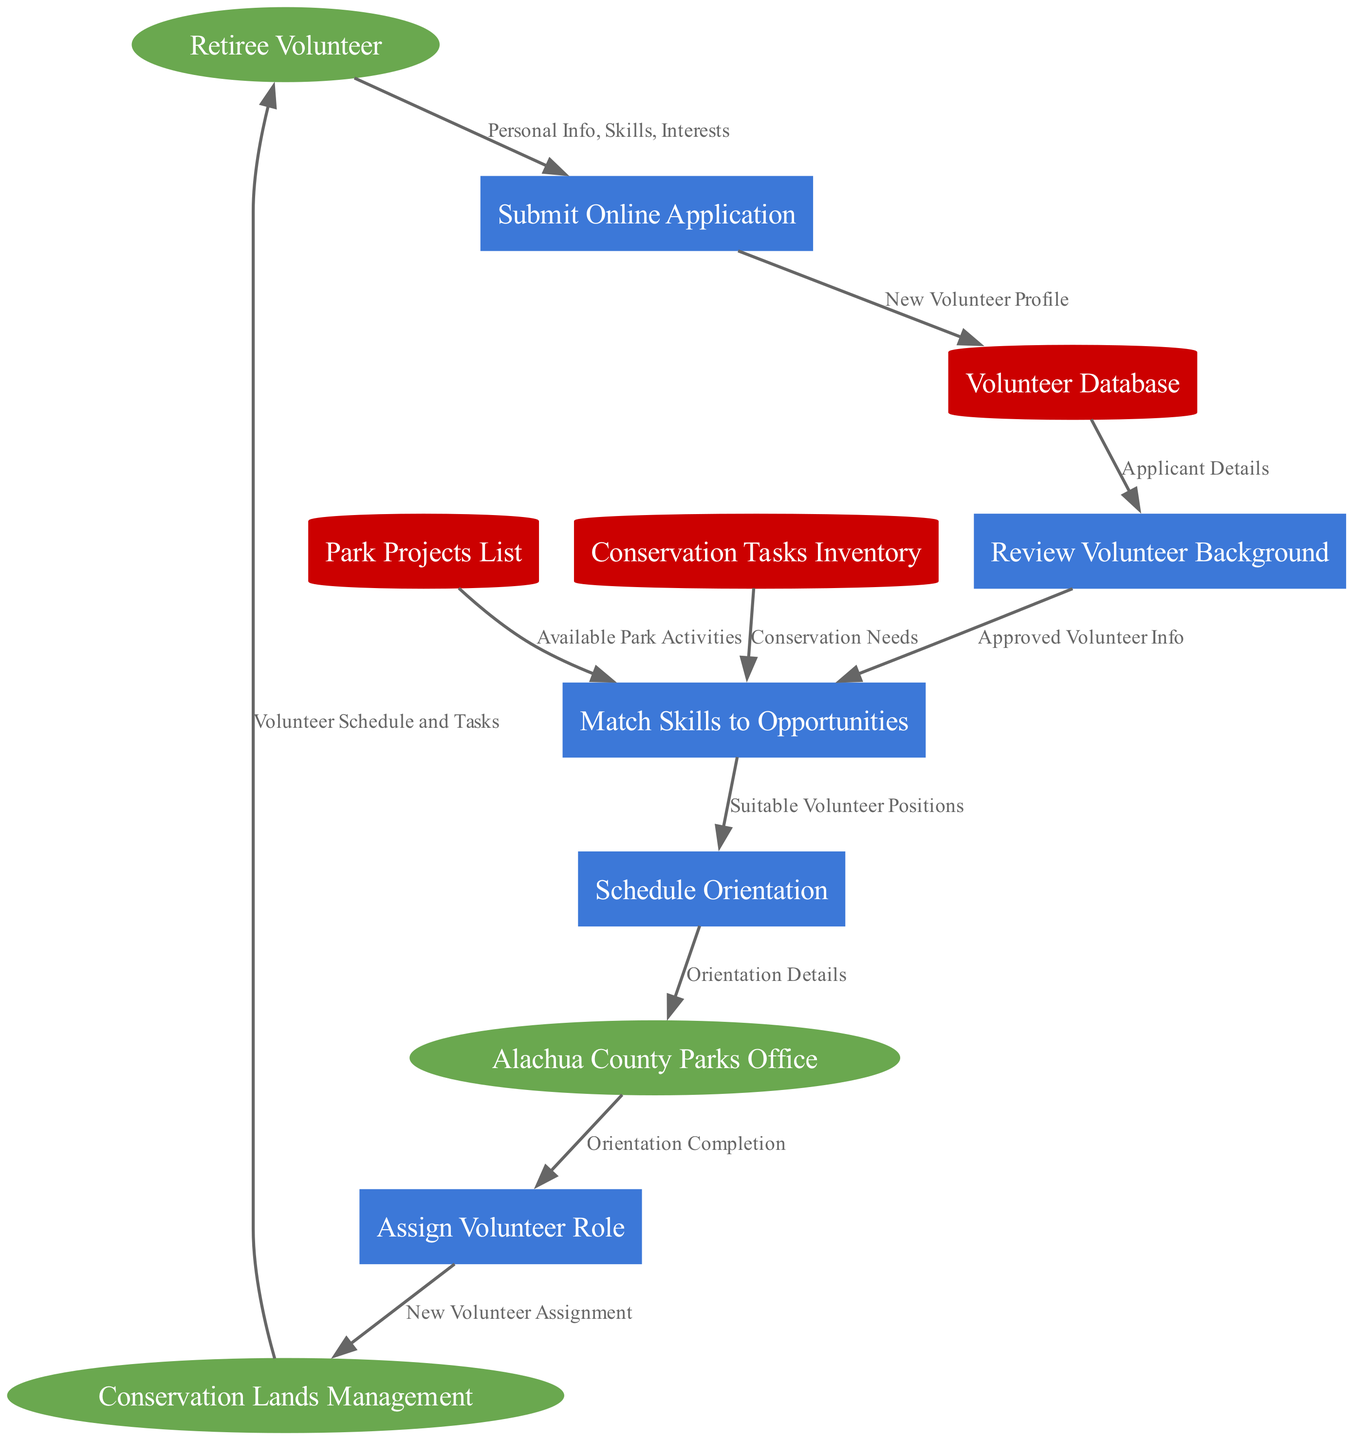What's the first step a retiree volunteer must take? The first step for a retiree volunteer is to submit an online application, which is indicated as the starting process in the diagram.
Answer: Submit Online Application How many processes are involved in the application and assignment process? By counting the processes listed in the diagram, we find there are five distinct processes mentioned for the application and assignment process.
Answer: Five What does the 'Match Skills to Opportunities' process utilize as input? The 'Match Skills to Opportunities' process takes two types of data as input: available park activities from the Park Projects List and conservation needs from the Conservation Tasks Inventory, which helps in finding suitable roles for volunteers.
Answer: Available Park Activities and Conservation Needs Which entity receives the orientation details after scheduling an orientation? According to the diagram, the orientation details are sent from the Scheduling Orientation process to the Alachua County Parks Office, which manages the orientation schedules.
Answer: Alachua County Parks Office What is the final output of the assign volunteer role process? The final output from the Assign Volunteer Role process is a new volunteer assignment that is directed to Conservation Lands Management, indicating that a role has been successfully assigned.
Answer: New Volunteer Assignment How does a retiree volunteer receive their schedule and tasks? The schedule and tasks are provided to the retiree volunteer from Conservation Lands Management, which is the last step in the data flow showing volunteer assignments and their associated tasks.
Answer: Volunteer Schedule and Tasks 